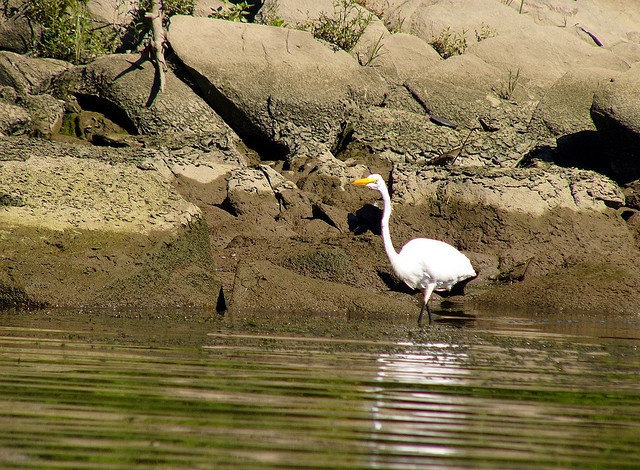Describe the objects in this image and their specific colors. I can see a bird in black, white, darkgray, and gray tones in this image. 